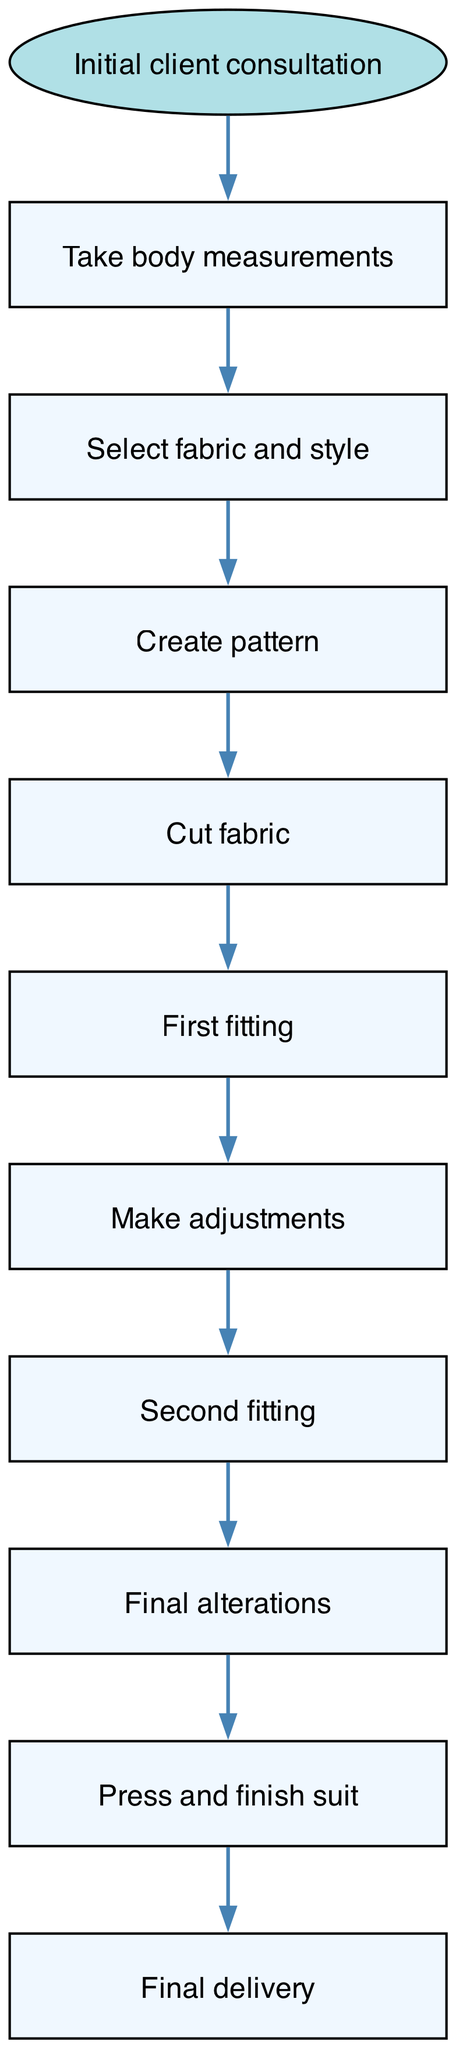What is the first step in the custom suit fitting process? The diagram indicates that the first step in the process is "Initial client consultation." This is the starting node, showing where the flow begins.
Answer: Initial client consultation How many nodes are there in the diagram? The diagram lists a total of ten nodes, including the start node and additional steps involved in the process. Each node represents a distinct part of the fitting process.
Answer: 10 Which step comes after "First fitting"? According to the flow of the diagram, the step that follows "First fitting" is "Make adjustments." The edges indicate the direction of the process progression.
Answer: Make adjustments What are the last two steps in the fitting process? The last two steps, shown by the edges leading from one node to the next, are "Press and finish suit" followed by "Final delivery." These indicate the concluding actions in the overall series.
Answer: Press and finish suit, Final delivery How many edges are there in the entire diagram? By examining the diagram, we can see that there are nine edges connecting ten nodes, indicating the sequence and relationship between the steps in the process.
Answer: 9 What is the relationship between "Second fitting" and "Final alterations"? The diagram shows that "Second fitting" directly leads to "Final alterations," indicating that alterations are made following the second fitting. This is a clear flow from one step to another.
Answer: Second fitting → Final alterations What type of node is "Initial client consultation"? The "Initial client consultation" node is illustrated as an ellipse, which is distinct in style from the rectangular nodes representing other steps in the process. This differentiation indicates it is the starting point.
Answer: Ellipse What node comes before "Create pattern"? The diagram indicates that the step preceding "Create pattern" is "Select fabric and style." This sequence is shown through the directed edges connecting these two nodes.
Answer: Select fabric and style 